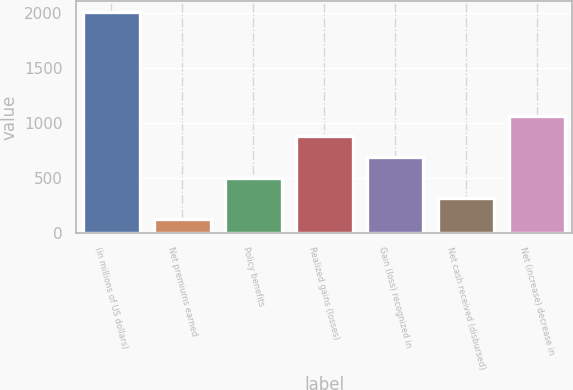Convert chart. <chart><loc_0><loc_0><loc_500><loc_500><bar_chart><fcel>(in millions of US dollars)<fcel>Net premiums earned<fcel>Policy benefits<fcel>Realized gains (losses)<fcel>Gain (loss) recognized in<fcel>Net cash received (disbursed)<fcel>Net (increase) decrease in<nl><fcel>2008<fcel>124<fcel>500.8<fcel>877.6<fcel>689.2<fcel>312.4<fcel>1066<nl></chart> 